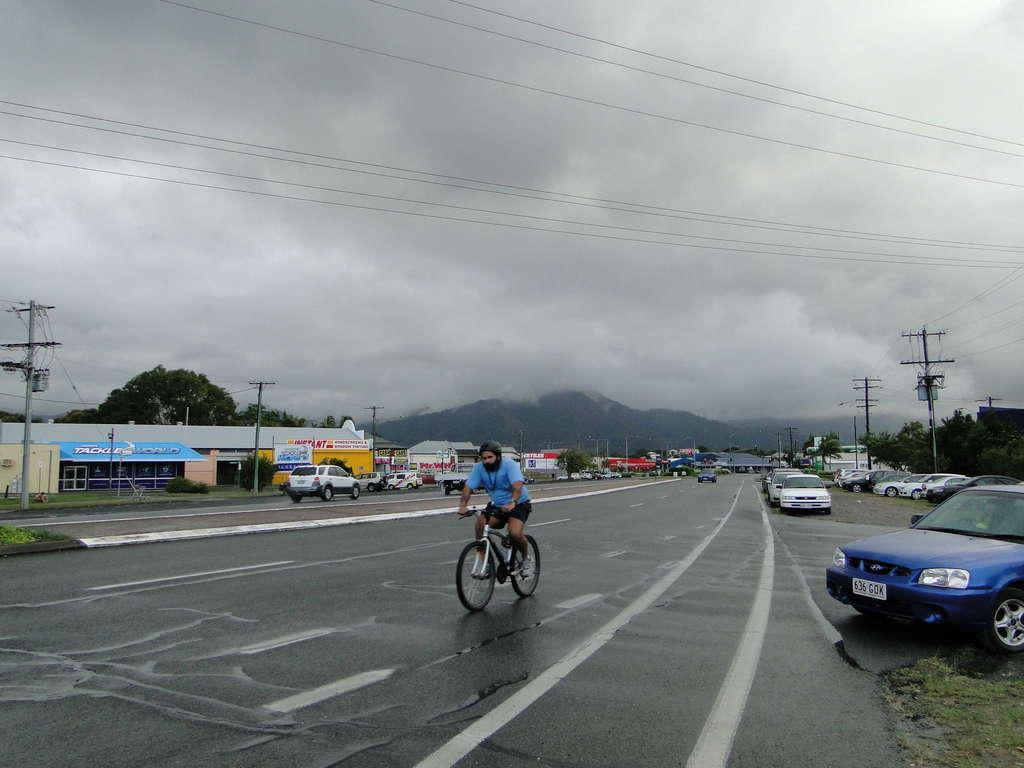What is the person in the image doing? There is a person riding a bicycle on the road in the image. What else can be seen on the road in the image? There are vehicles in the image. What type of establishments are visible in the image? There are shops in the image. What natural elements can be seen in the image? There are trees and hills in the image. What structures are present along the road in the image? There are poles in the image. What is visible in the background of the image? The sky is visible in the image. What type of song can be heard coming from the snails in the image? There are no snails present in the image, so it's not possible to determine what, if any, song might be heard. 